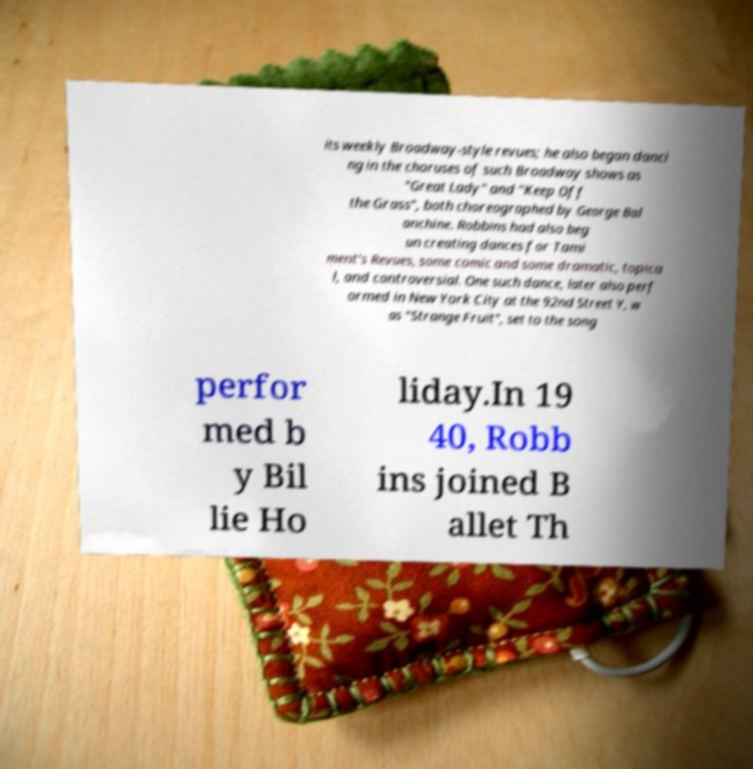I need the written content from this picture converted into text. Can you do that? its weekly Broadway-style revues; he also began danci ng in the choruses of such Broadway shows as "Great Lady" and "Keep Off the Grass", both choreographed by George Bal anchine. Robbins had also beg un creating dances for Tami ment's Revues, some comic and some dramatic, topica l, and controversial. One such dance, later also perf ormed in New York City at the 92nd Street Y, w as "Strange Fruit", set to the song perfor med b y Bil lie Ho liday.In 19 40, Robb ins joined B allet Th 